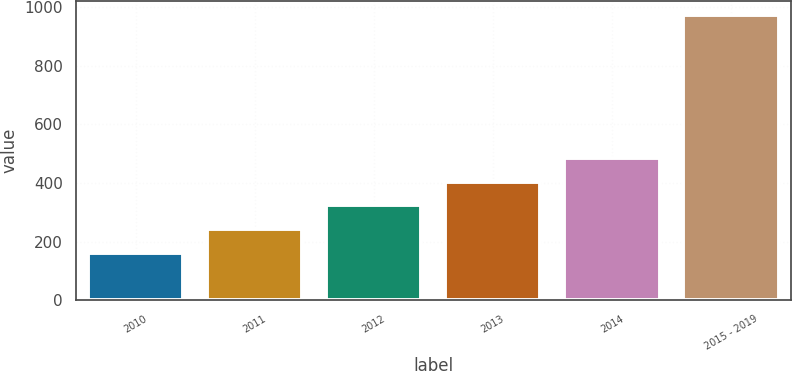Convert chart to OTSL. <chart><loc_0><loc_0><loc_500><loc_500><bar_chart><fcel>2010<fcel>2011<fcel>2012<fcel>2013<fcel>2014<fcel>2015 - 2019<nl><fcel>161<fcel>242.3<fcel>323.6<fcel>404.9<fcel>486.2<fcel>974<nl></chart> 